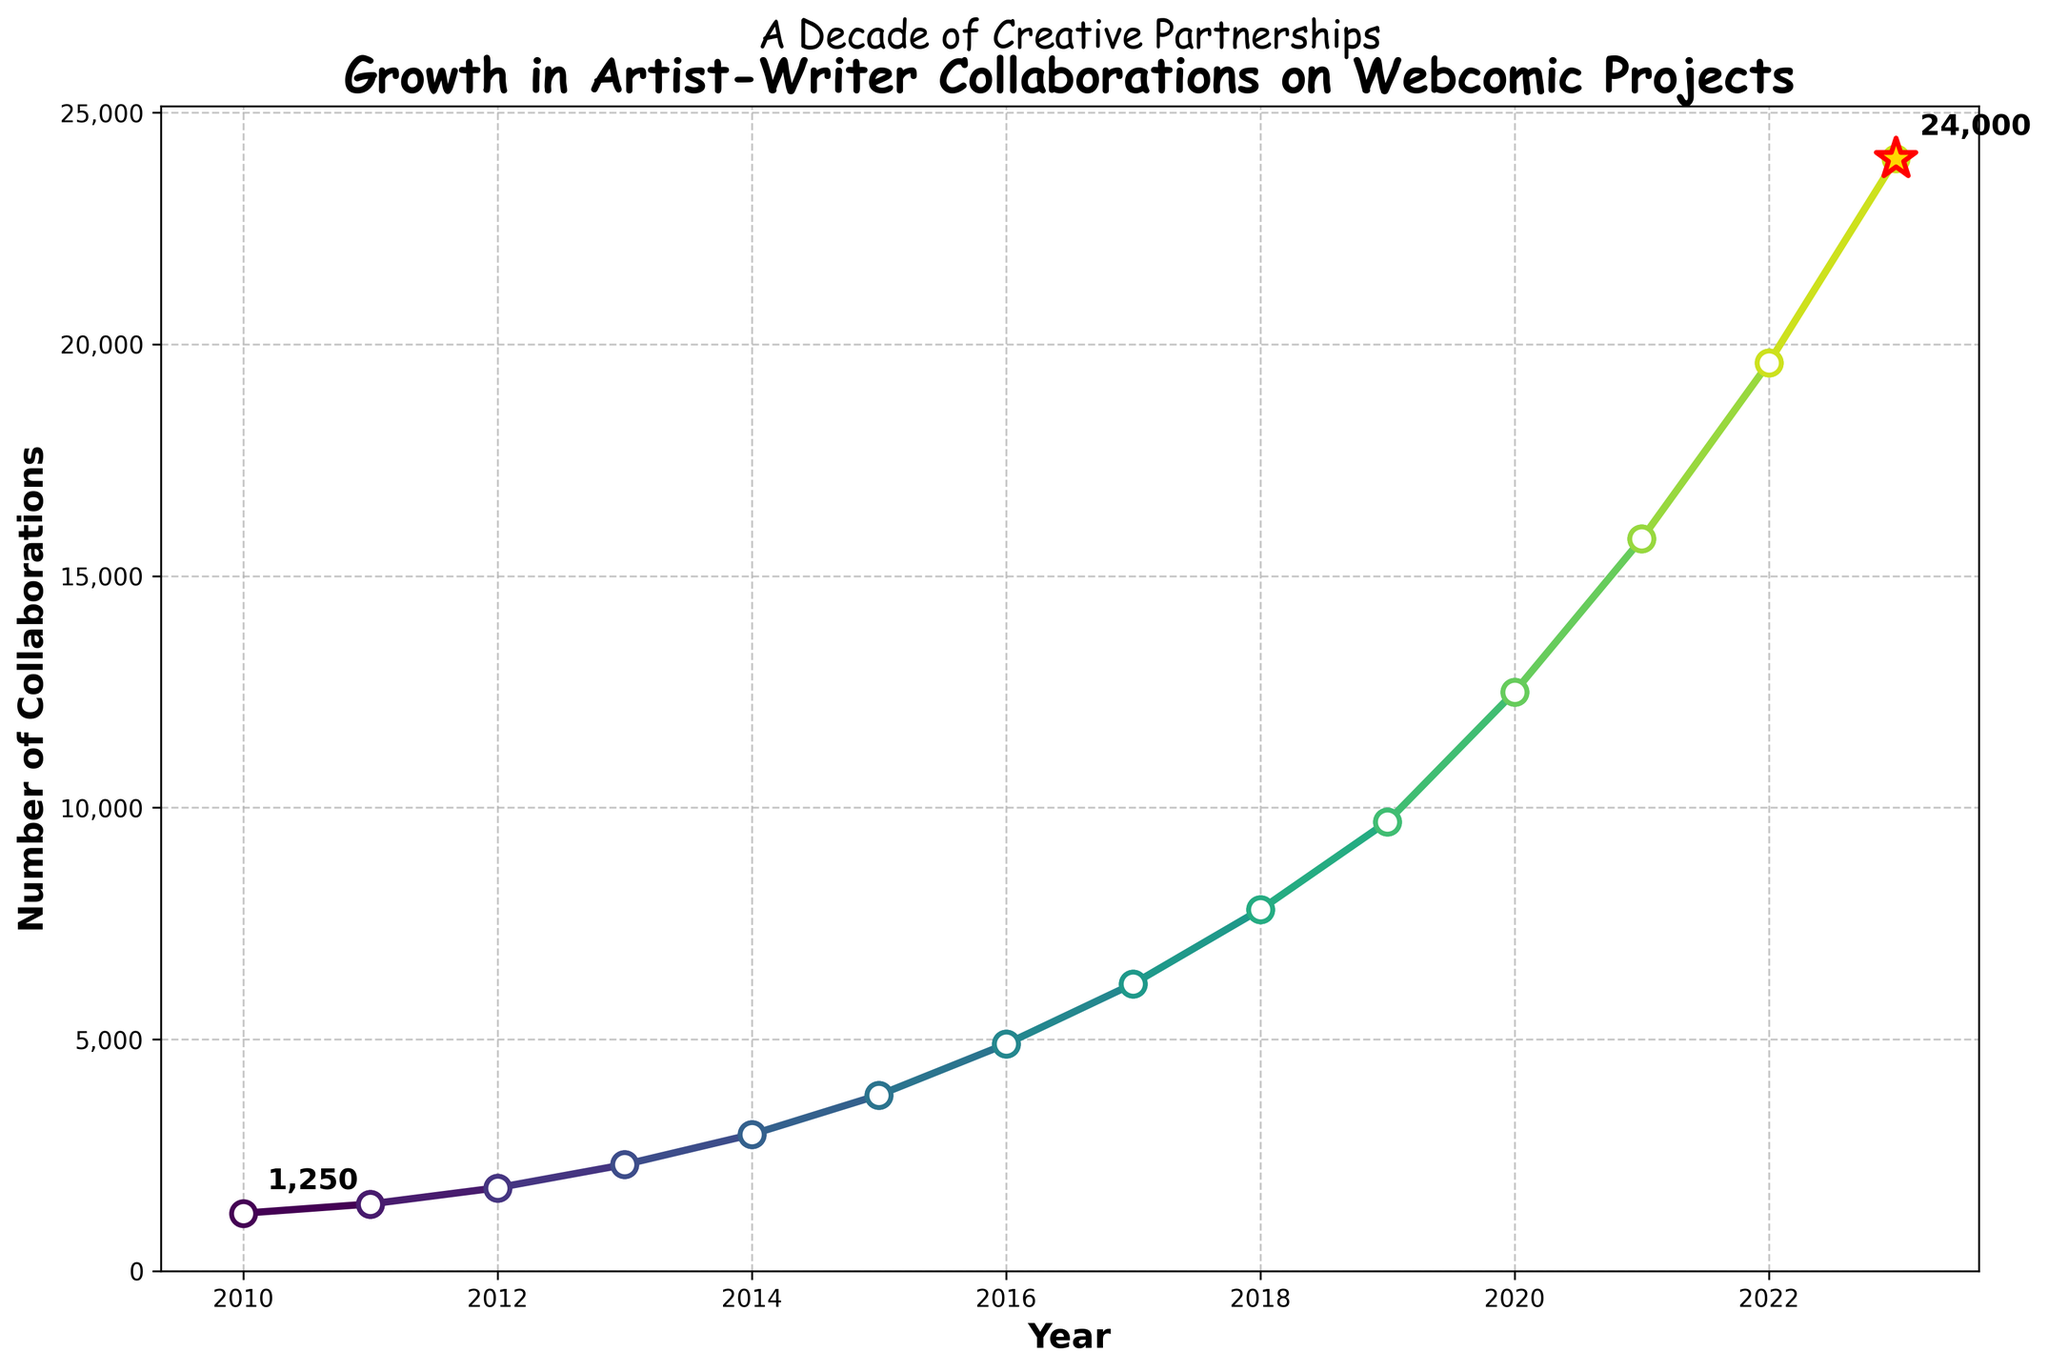What's the difference in the number of collaborations between 2023 and 2010? To find the difference, subtract the number of collaborations in 2010 from the number in 2023. The values are 24,000 for 2023 and 1,250 for 2010. 24,000 - 1,250 = 22,750
Answer: 22,750 Which year had the highest growth in the number of collaborations compared to the previous year? To determine the highest growth, calculate the difference in collaborations for each consecutive year and find the maximum. Between 2020 and 2021, the growth is: 15,800 - 12,500 = 3,300, which is the highest.
Answer: 2021 What is the average number of collaborations from 2010 to 2023? Sum the total number of collaborations over the years and divide by the number of years. (1,250 + 1,450 + 1,800 + 2,300 + 2,950 + 3,800 + 4,900 + 6,200 + 7,800 + 9,700 + 12,500 + 15,800 + 19,600 + 24,000) / 14 ≈ 7,557
Answer: 7,557 What visual element indicates the data point for 2023? The data point for 2023 is marked with a comic-style explosion: a large, gold star with a red edge.
Answer: Gold star with red edge How many times did the number of collaborations increase by more than 1,000 from one year to the next? Count the annual increments exceeding 1,000 by comparing consecutive years. These years are: 2011 (200), 2012 (350), 2013 (500), 2014 (650), 2015 (850), 2016 (1,100), 2017 (1,300), 2018 (1,600), 2019 (1,900), 2020 (2,800), 2021 (3,300), 2022 (3,800), and 2023 (4,400).
Answer: 13 During which year did collaborations first exceed 5,000? Identify the first year where the number of collaborations is greater than 5,000. This occurs in 2017 with 6,200.
Answer: 2017 What is the median number of collaborations from 2010 to 2023? List the values from smallest to largest and find the middle value. The list is: 1,250, 1,450, 1,800, 2,300, 2,950, 3,800, 4,900, 6,200, 7,800, 9,700, 12,500, 15,800, 19,600, 24,000. Median is (4,900+6,200)/2 = 5,550
Answer: 5,550 Compare the growth rate from 2015 to 2020 and from 2020 to 2023. Which period had a higher growth rate? Calculate the growth rates: (12,500-3,800)/3,800 ≈ 2.29 for 2015 to 2020, and (24,000-12,500)/12,500 = 0.92 for 2020 to 2023. 2.29 > 0.92
Answer: 2015 to 2020 